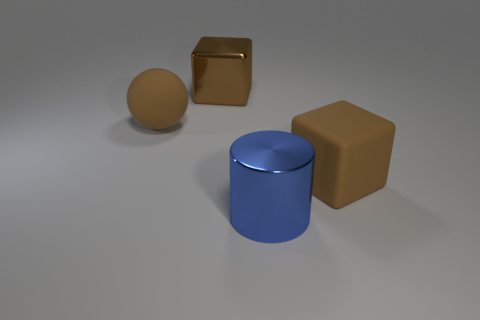Is there any other thing that has the same shape as the big blue object?
Offer a very short reply. No. What number of objects are either metallic objects that are behind the brown ball or big blue shiny objects?
Keep it short and to the point. 2. Does the block in front of the big rubber ball have the same color as the big metallic block?
Offer a terse response. Yes. There is a object on the left side of the large metal thing that is behind the big brown rubber ball; what shape is it?
Provide a succinct answer. Sphere. Is the number of big things that are on the left side of the brown matte ball less than the number of objects to the right of the big blue thing?
Make the answer very short. Yes. How many objects are big shiny objects that are behind the large blue shiny object or brown blocks to the right of the big blue shiny object?
Make the answer very short. 2. Is the size of the brown matte block the same as the blue thing?
Offer a very short reply. Yes. Is the number of brown shiny cubes greater than the number of tiny green metal cubes?
Give a very brief answer. Yes. What number of other things are there of the same color as the rubber cube?
Provide a succinct answer. 2. How many things are either brown things or big rubber things?
Provide a short and direct response. 3. 